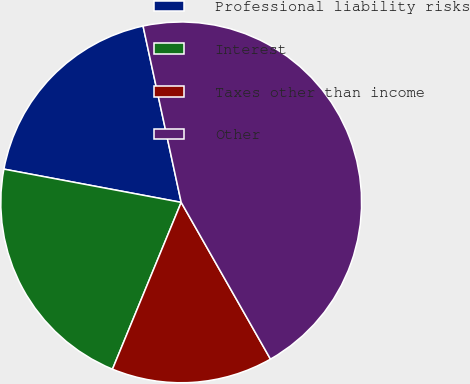Convert chart to OTSL. <chart><loc_0><loc_0><loc_500><loc_500><pie_chart><fcel>Professional liability risks<fcel>Interest<fcel>Taxes other than income<fcel>Other<nl><fcel>18.66%<fcel>21.73%<fcel>14.46%<fcel>45.15%<nl></chart> 